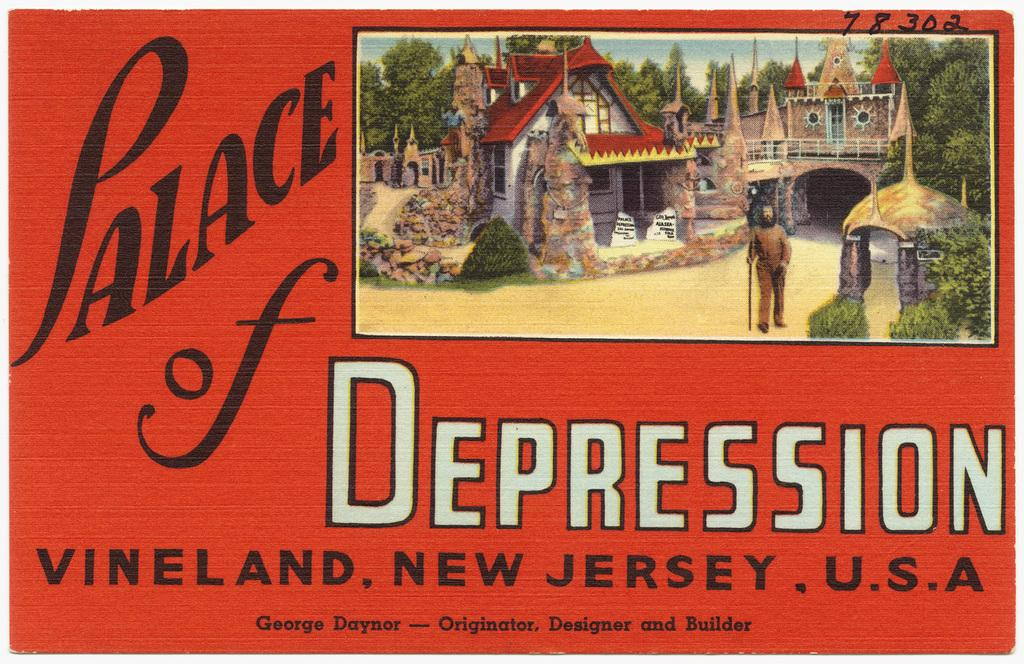What type of visual is the image in question? The image is a poster. What is the main subject of the poster? There is an image of a person on the poster. What other elements can be seen on the poster? Houses, trees, and plants are visible on the poster. What type of music can be heard playing in the background of the poster? There is no music present in the poster, as it is a visual image and not an audio recording. 